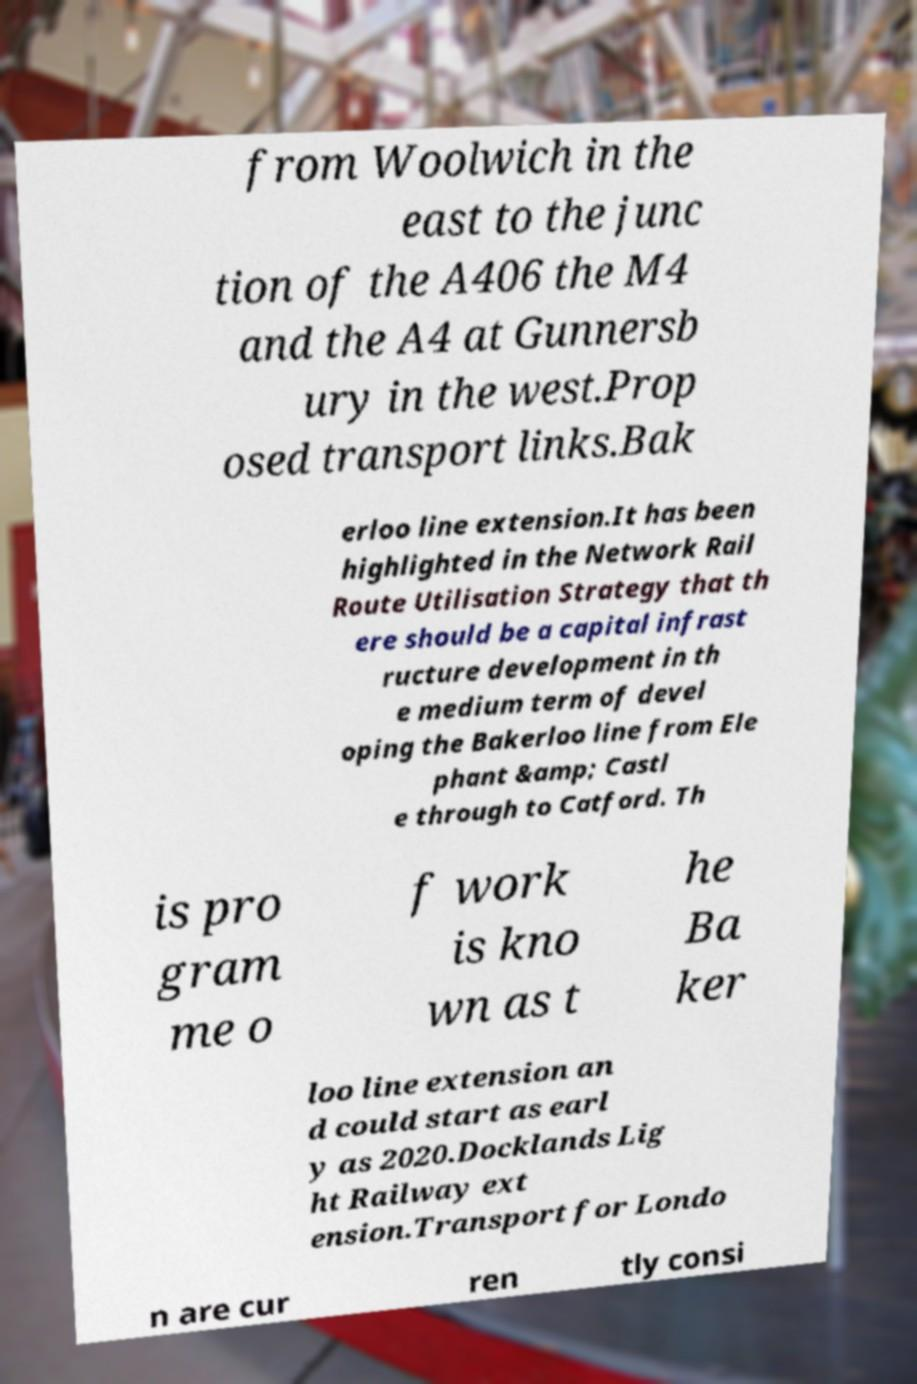Please identify and transcribe the text found in this image. from Woolwich in the east to the junc tion of the A406 the M4 and the A4 at Gunnersb ury in the west.Prop osed transport links.Bak erloo line extension.It has been highlighted in the Network Rail Route Utilisation Strategy that th ere should be a capital infrast ructure development in th e medium term of devel oping the Bakerloo line from Ele phant &amp; Castl e through to Catford. Th is pro gram me o f work is kno wn as t he Ba ker loo line extension an d could start as earl y as 2020.Docklands Lig ht Railway ext ension.Transport for Londo n are cur ren tly consi 